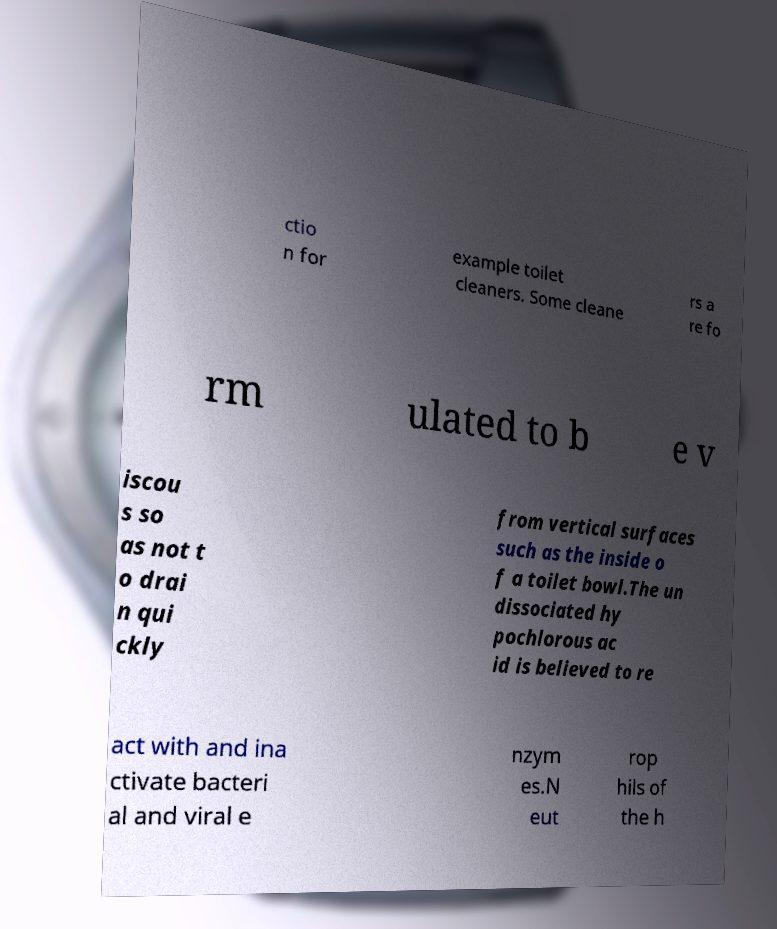Can you read and provide the text displayed in the image?This photo seems to have some interesting text. Can you extract and type it out for me? ctio n for example toilet cleaners. Some cleane rs a re fo rm ulated to b e v iscou s so as not t o drai n qui ckly from vertical surfaces such as the inside o f a toilet bowl.The un dissociated hy pochlorous ac id is believed to re act with and ina ctivate bacteri al and viral e nzym es.N eut rop hils of the h 